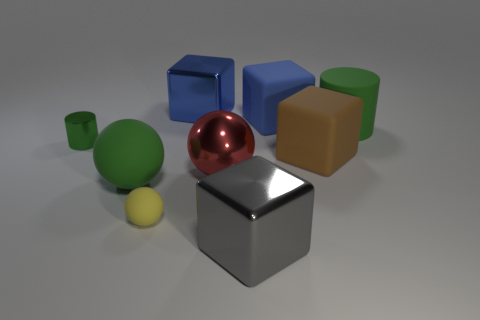Subtract all metallic balls. How many balls are left? 2 Subtract all cubes. How many objects are left? 5 Subtract 1 cylinders. How many cylinders are left? 1 Subtract all gray cubes. How many cubes are left? 3 Subtract all gray cylinders. How many yellow blocks are left? 0 Subtract all large purple shiny objects. Subtract all matte cubes. How many objects are left? 7 Add 3 matte objects. How many matte objects are left? 8 Add 4 gray objects. How many gray objects exist? 5 Add 1 rubber cylinders. How many objects exist? 10 Subtract 1 green balls. How many objects are left? 8 